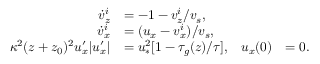<formula> <loc_0><loc_0><loc_500><loc_500>\begin{array} { r l r l } { \dot { v } _ { z } ^ { i } } & { = - 1 - v _ { z } ^ { i } / v _ { s } , } \\ { \dot { v } _ { x } ^ { i } } & { = ( u _ { x } - v _ { x } ^ { i } ) / v _ { s } , } \\ { \kappa ^ { 2 } ( z + z _ { 0 } ) ^ { 2 } u _ { x } ^ { \prime } | u _ { x } ^ { \prime } | } & { = u _ { \ast } ^ { 2 } [ 1 - \tau _ { g } ( z ) / \tau ] , } & { u _ { x } ( 0 ) } & { = 0 . } \end{array}</formula> 